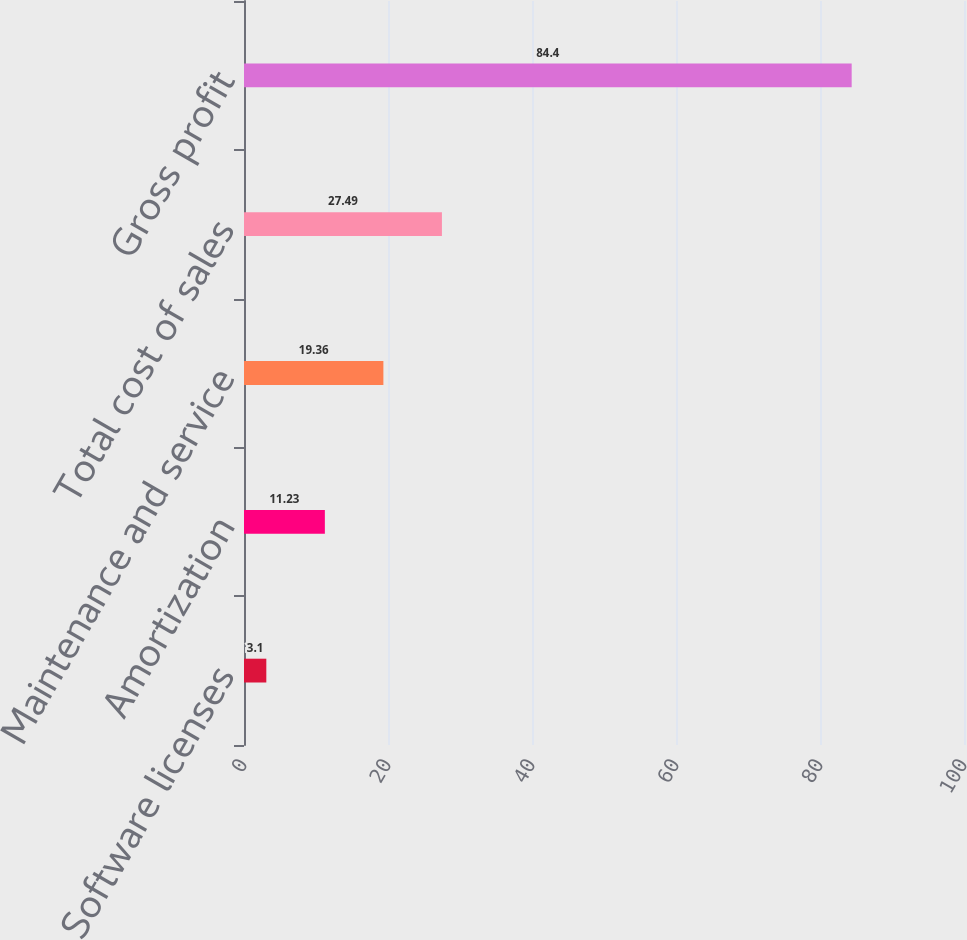<chart> <loc_0><loc_0><loc_500><loc_500><bar_chart><fcel>Software licenses<fcel>Amortization<fcel>Maintenance and service<fcel>Total cost of sales<fcel>Gross profit<nl><fcel>3.1<fcel>11.23<fcel>19.36<fcel>27.49<fcel>84.4<nl></chart> 